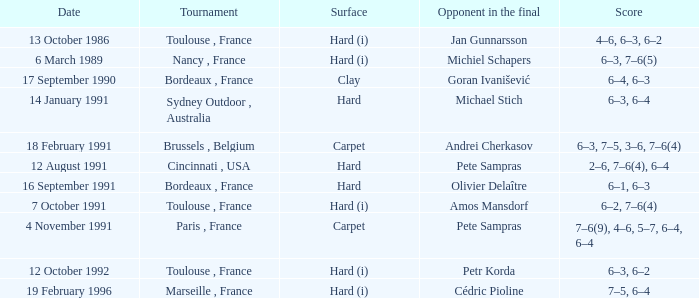What is the score of the tournament with olivier delaître as the opponent in the final? 6–1, 6–3. 